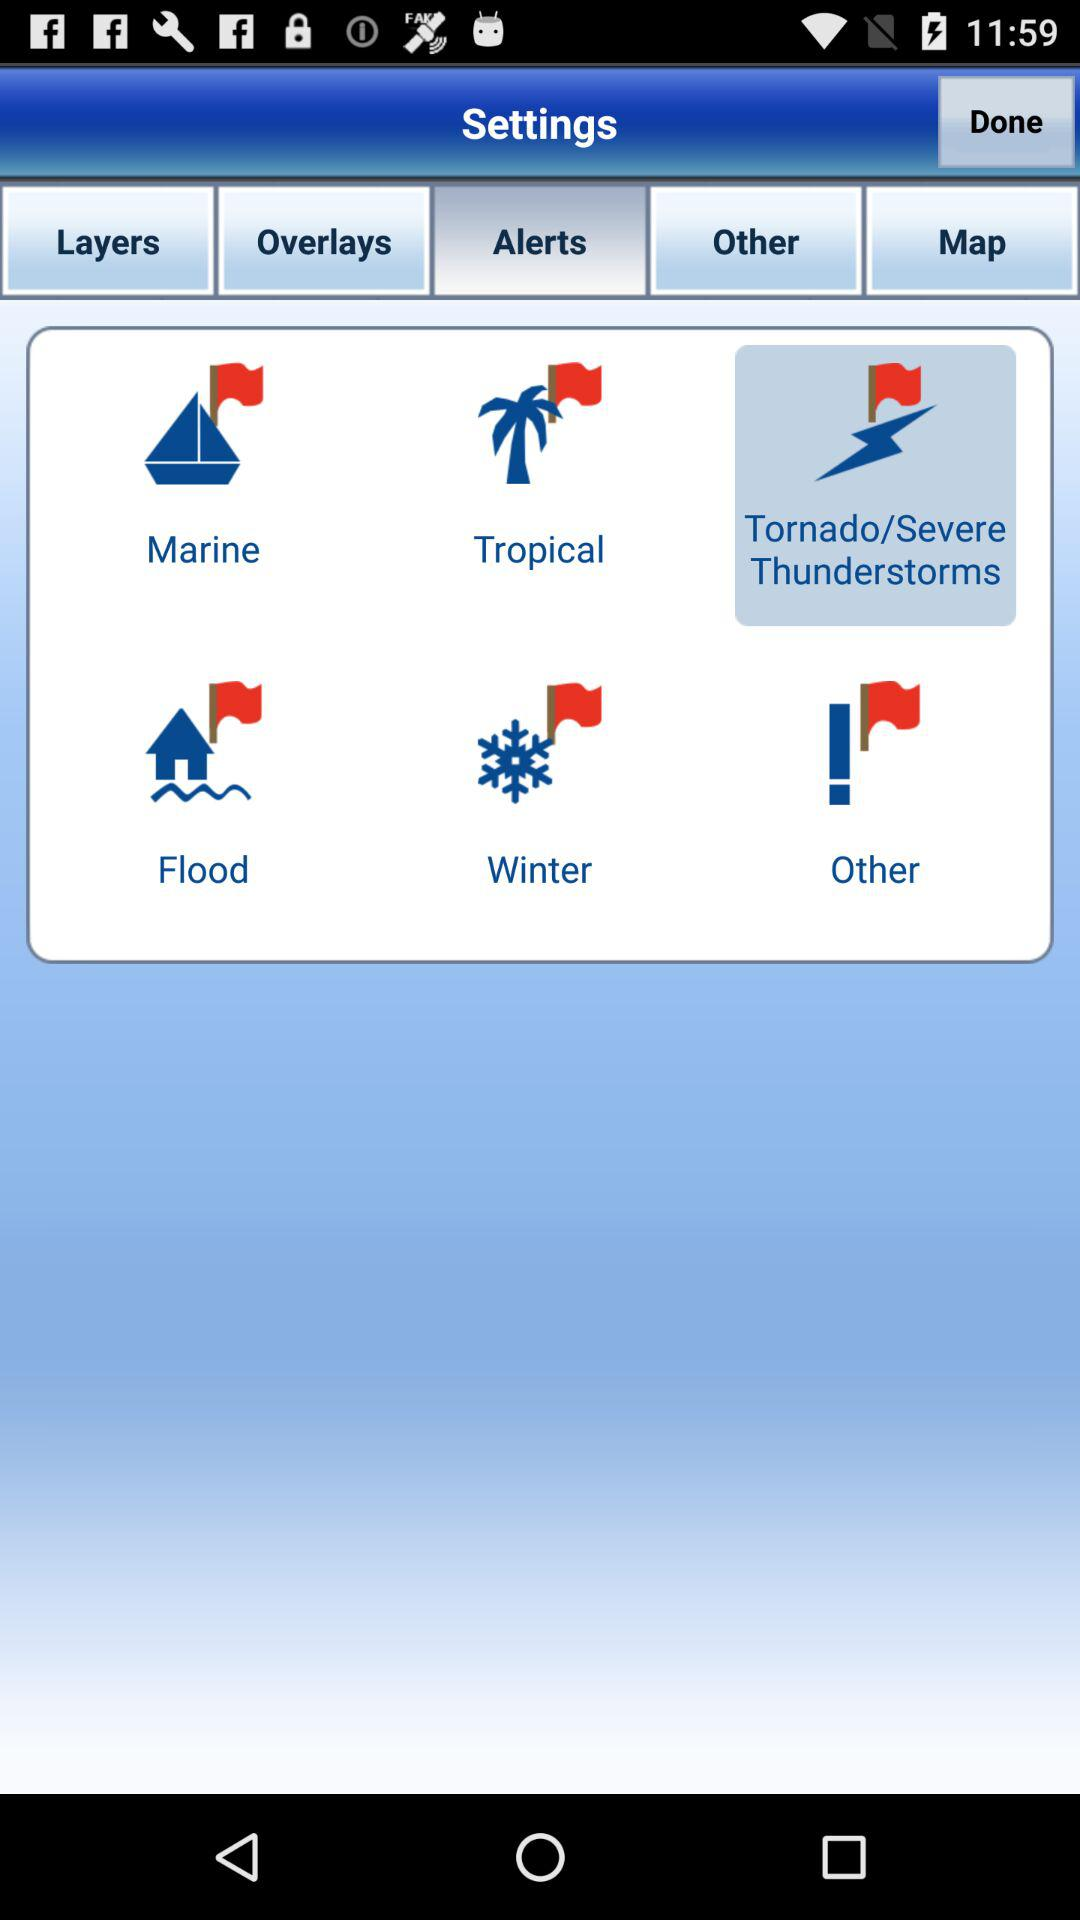Which layer options are there?
When the provided information is insufficient, respond with <no answer>. <no answer> 